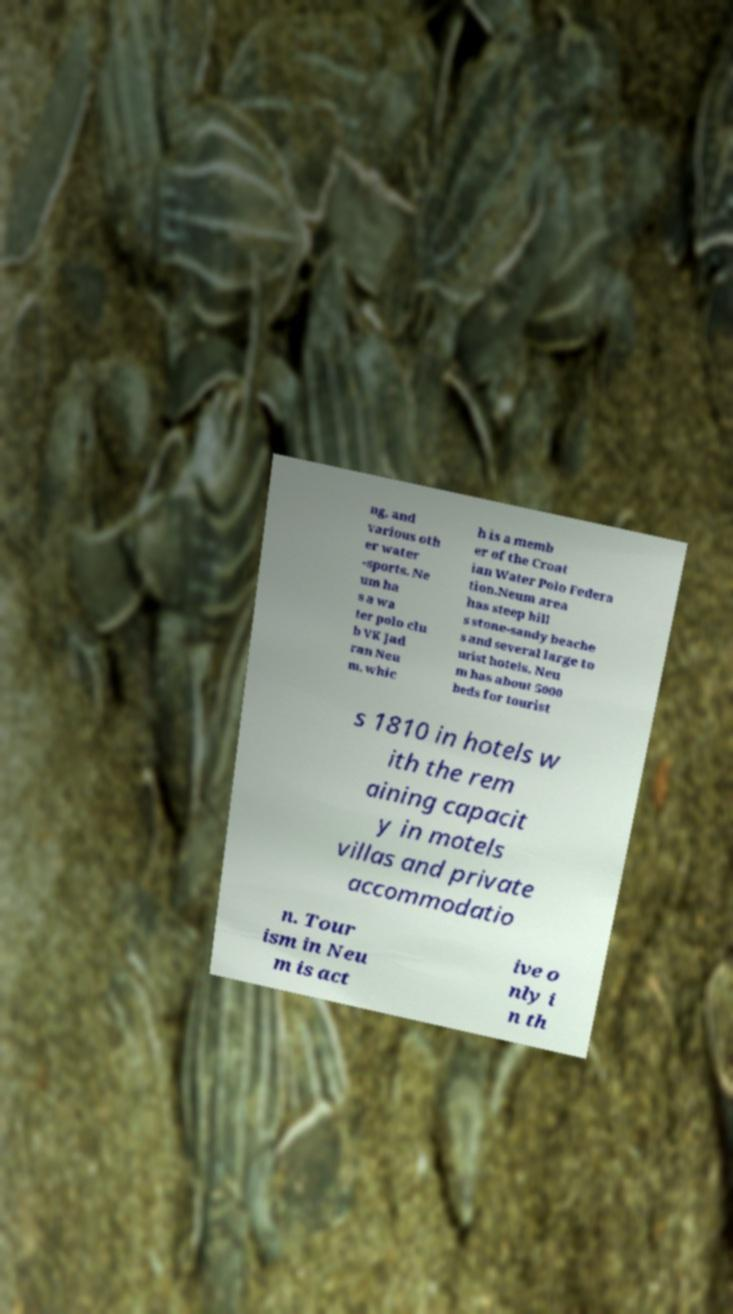I need the written content from this picture converted into text. Can you do that? ng, and various oth er water -sports. Ne um ha s a wa ter polo clu b VK Jad ran Neu m, whic h is a memb er of the Croat ian Water Polo Federa tion.Neum area has steep hill s stone-sandy beache s and several large to urist hotels. Neu m has about 5000 beds for tourist s 1810 in hotels w ith the rem aining capacit y in motels villas and private accommodatio n. Tour ism in Neu m is act ive o nly i n th 